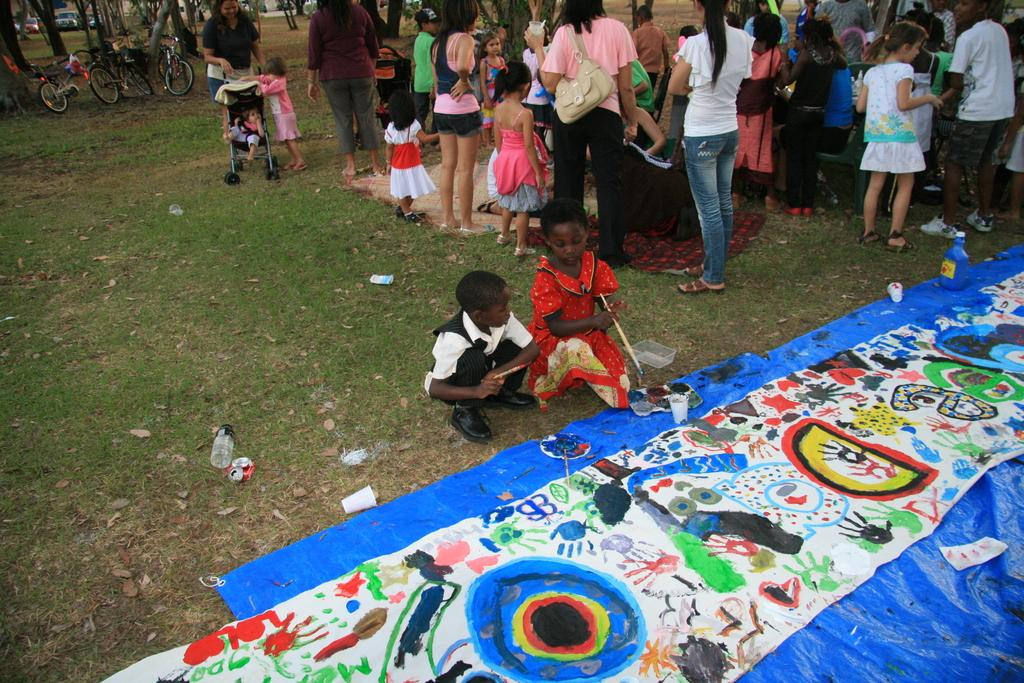How many people are in the image? There are multiple people standing in a group in the image. What are two people doing in the image? Two people are sitting and painting on the ground. Where are the bicycles located in the image? The bicycles are under a tree. What might the people in the group be doing together? They might be participating in a group activity or socializing. What type of ghost can be seen haunting the bicycles under the tree in the image? There are no ghosts present in the image; it features people standing in a group, two people painting on the ground, and bicycles under a tree. 